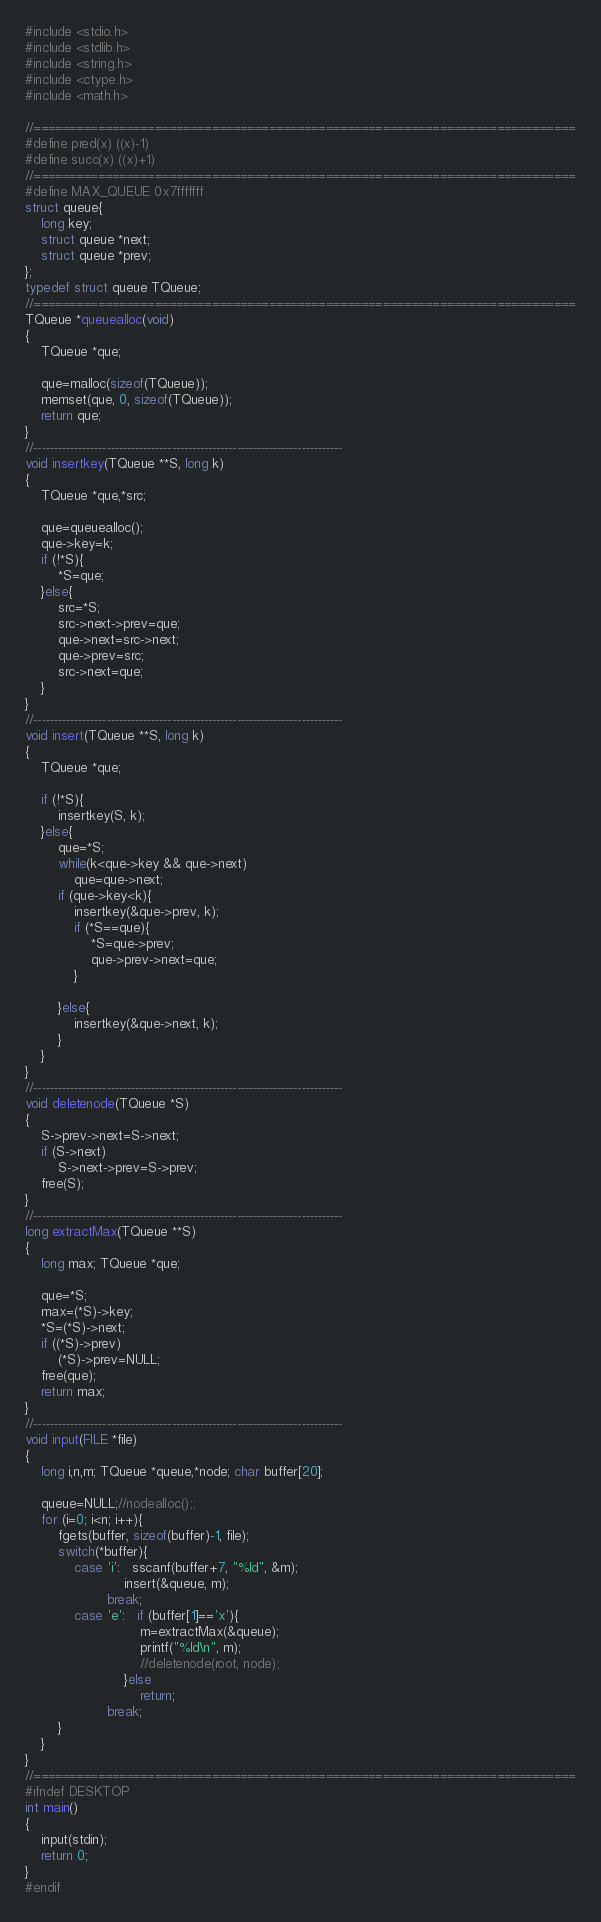<code> <loc_0><loc_0><loc_500><loc_500><_C_>#include <stdio.h>
#include <stdlib.h>
#include <string.h>
#include <ctype.h>
#include <math.h>

//============================================================================
#define pred(x) ((x)-1)
#define succ(x) ((x)+1)
//============================================================================
#define MAX_QUEUE 0x7fffffff
struct queue{
    long key;
    struct queue *next;
    struct queue *prev;
};
typedef struct queue TQueue;
//============================================================================
TQueue *queuealloc(void)
{
    TQueue *que;

    que=malloc(sizeof(TQueue));
    memset(que, 0, sizeof(TQueue));
    return que;
}
//----------------------------------------------------------------------------
void insertkey(TQueue **S, long k)
{
    TQueue *que,*src;

    que=queuealloc();
    que->key=k;
    if (!*S){
        *S=que;
    }else{
        src=*S;
        src->next->prev=que;
        que->next=src->next;
        que->prev=src;
        src->next=que;
    }
}
//----------------------------------------------------------------------------
void insert(TQueue **S, long k)
{
    TQueue *que;

    if (!*S){
        insertkey(S, k);
    }else{
        que=*S;
        while(k<que->key && que->next)
            que=que->next;
        if (que->key<k){
            insertkey(&que->prev, k);
            if (*S==que){
                *S=que->prev;
                que->prev->next=que;
            }

        }else{
            insertkey(&que->next, k);
        }
    }
}
//----------------------------------------------------------------------------
void deletenode(TQueue *S)
{
    S->prev->next=S->next;
    if (S->next)
        S->next->prev=S->prev;
    free(S);
}
//----------------------------------------------------------------------------
long extractMax(TQueue **S)
{
    long max; TQueue *que;

    que=*S;
    max=(*S)->key;
    *S=(*S)->next;
    if ((*S)->prev)
        (*S)->prev=NULL;
    free(que);
    return max;
}
//----------------------------------------------------------------------------
void input(FILE *file)
{
    long i,n,m; TQueue *queue,*node; char buffer[20];

    queue=NULL;//nodealloc();;
    for (i=0; i<n; i++){
        fgets(buffer, sizeof(buffer)-1, file);
        switch(*buffer){
            case 'i':   sscanf(buffer+7, "%ld", &m);
                        insert(&queue, m);
                    break;
            case 'e':   if (buffer[1]=='x'){
                            m=extractMax(&queue);
                            printf("%ld\n", m);
                            //deletenode(root, node);
                        }else
                            return;
                    break;
        }
    }
}
//============================================================================
#ifndef DESKTOP
int main()
{
    input(stdin);
    return 0;
}
#endif</code> 